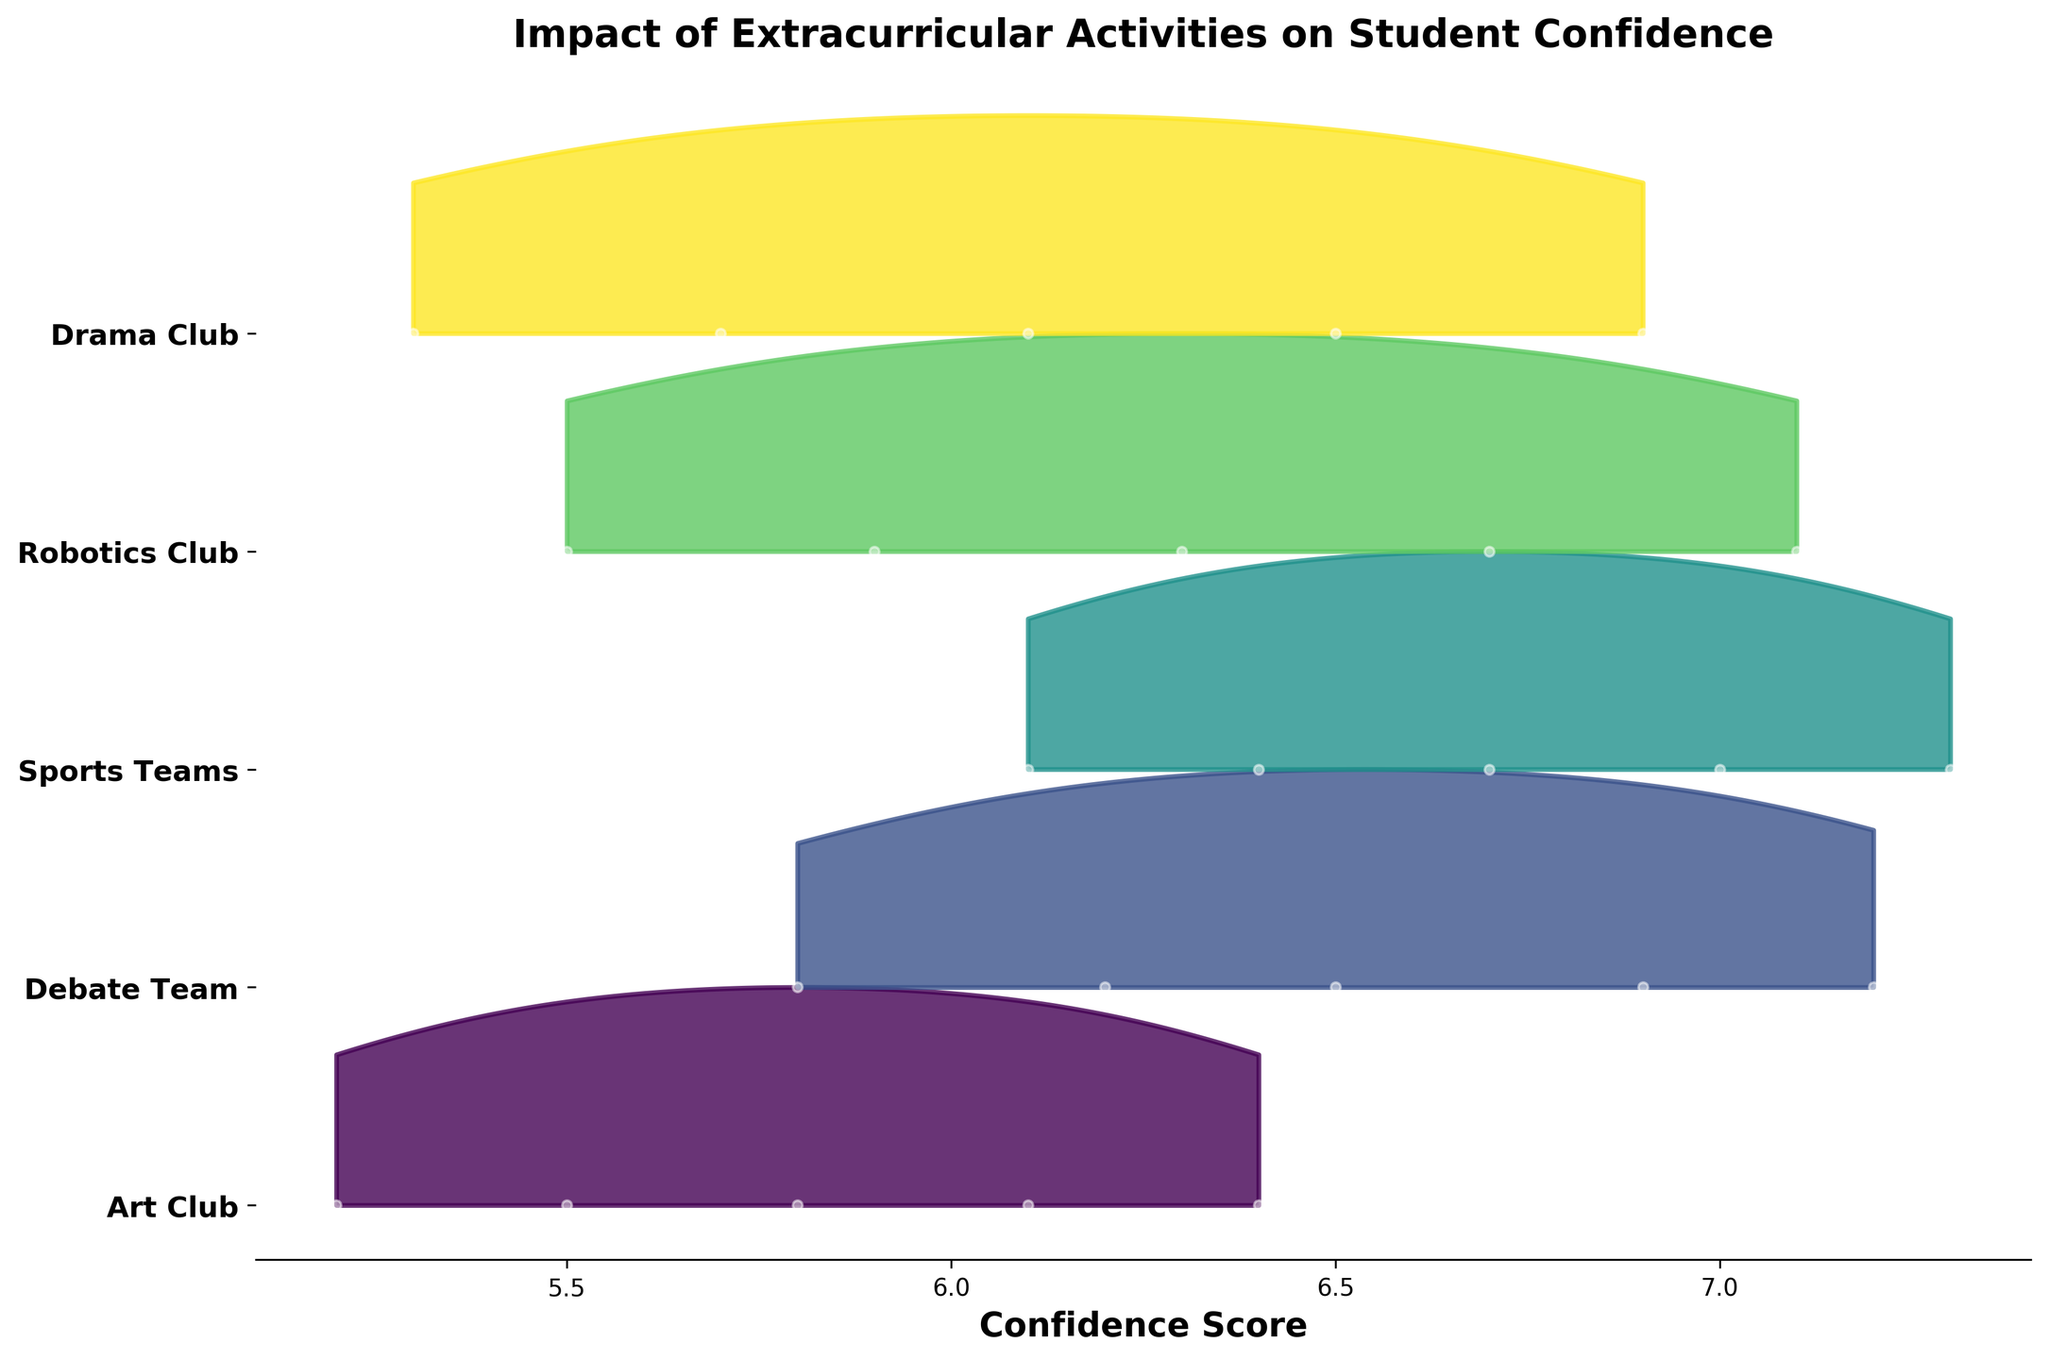What is the title of the plot? The title is usually positioned at the top of the plot and serves to summarize the information presented.
Answer: Impact of Extracurricular Activities on Student Confidence How many extracurricular activities are shown in the plot? There are unique sets of data points for each activity, which can be identified by the ridgelines or distribution bands associated with each label on the y-axis. Count these labels to determine the number of activities.
Answer: 5 Which extracurricular activity shows the highest confidence scores in May? Identify the endpoint of each ridgeline for the month of May and see which one has the highest value on the confidence score axis.
Answer: Sports Teams Which activity has the steepest increase in confidence scores over the months? To find the activity with the steepest increase, compare the confidence scores from January to May for each activity and identify which one has the largest increase in values.
Answer: Debate Team On average, which activity's confidence scores lie between the confidence scores of Art Club and Debate Team? Compare the ridgelines for each activity, focusing on the density peaks relative to both Art Club and Debate Team, to see which activity is centrally positioned between their distributions.
Answer: Robotics Club How does the confidence score distribution of Drama Club in March compare to the other activities? Look at the position and spread of the ridgeline for Drama Club in March, and compare its density peak and spread to the other activities' ridgelines at the same point.
Answer: Drama Club has lower confidence scores compared to most other activities Which activity has the lowest starting confidence score in January? Find the ridgeline section for January and identify the activity whose distribution starts at the lowest point on the confidence score axis.
Answer: Art Club If a student wanted to join an activity where confidence increases consistently each month, which activity should they consider? Look at the trends of the ridgelines from January to May and identify the activity that shows consistent incremental gains in confidence scores each month.
Answer: Robotics Club What is the general pattern of confidence scores across the activities and months? Summarize the overall trends in the ridgelines, noting whether most activities show increases, decreases, or fluctuating confidence scores over time.
Answer: Most activities show a consistent increase in confidence scores from January to May 